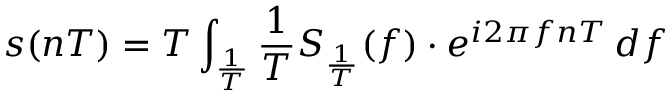<formula> <loc_0><loc_0><loc_500><loc_500>s ( n T ) = T \int _ { \frac { 1 } { T } } { \frac { 1 } { T } } S _ { \frac { 1 } { T } } ( f ) \cdot e ^ { i 2 \pi f n T } \, d f</formula> 